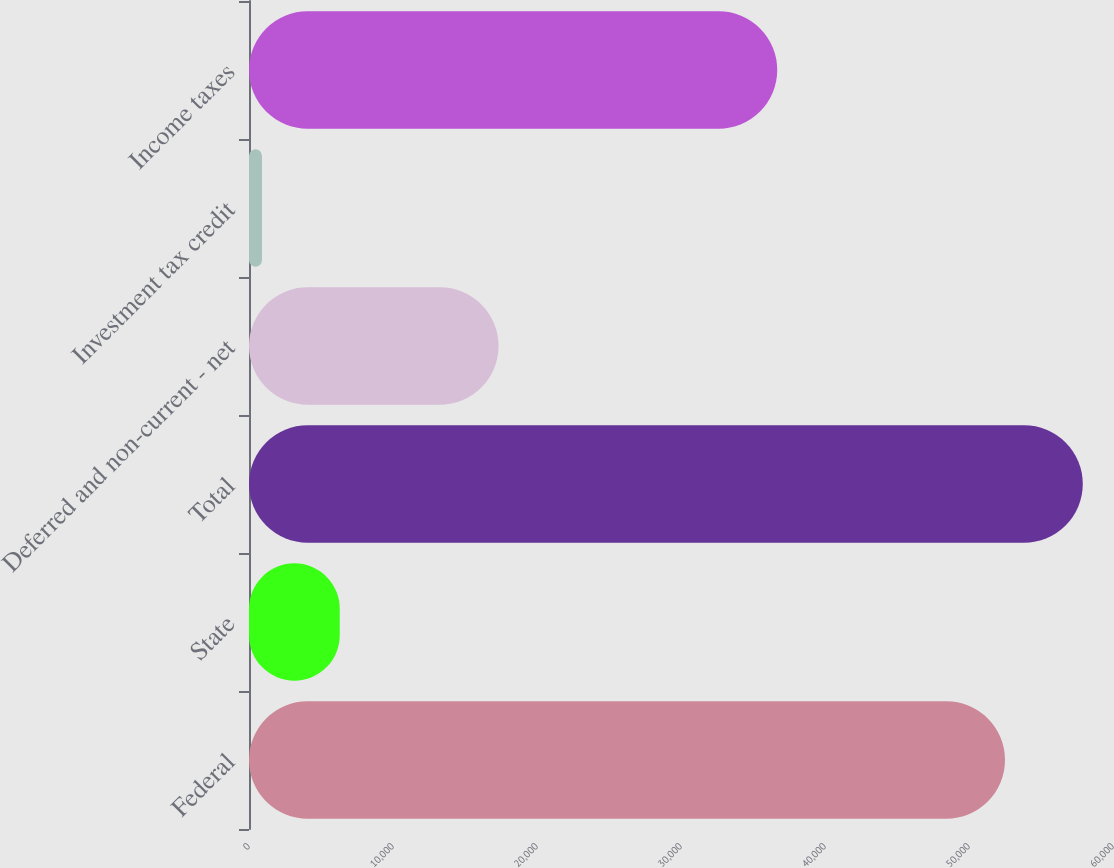Convert chart to OTSL. <chart><loc_0><loc_0><loc_500><loc_500><bar_chart><fcel>Federal<fcel>State<fcel>Total<fcel>Deferred and non-current - net<fcel>Investment tax credit<fcel>Income taxes<nl><fcel>53313<fcel>6398.9<fcel>58797.9<fcel>17599<fcel>914<fcel>37250<nl></chart> 